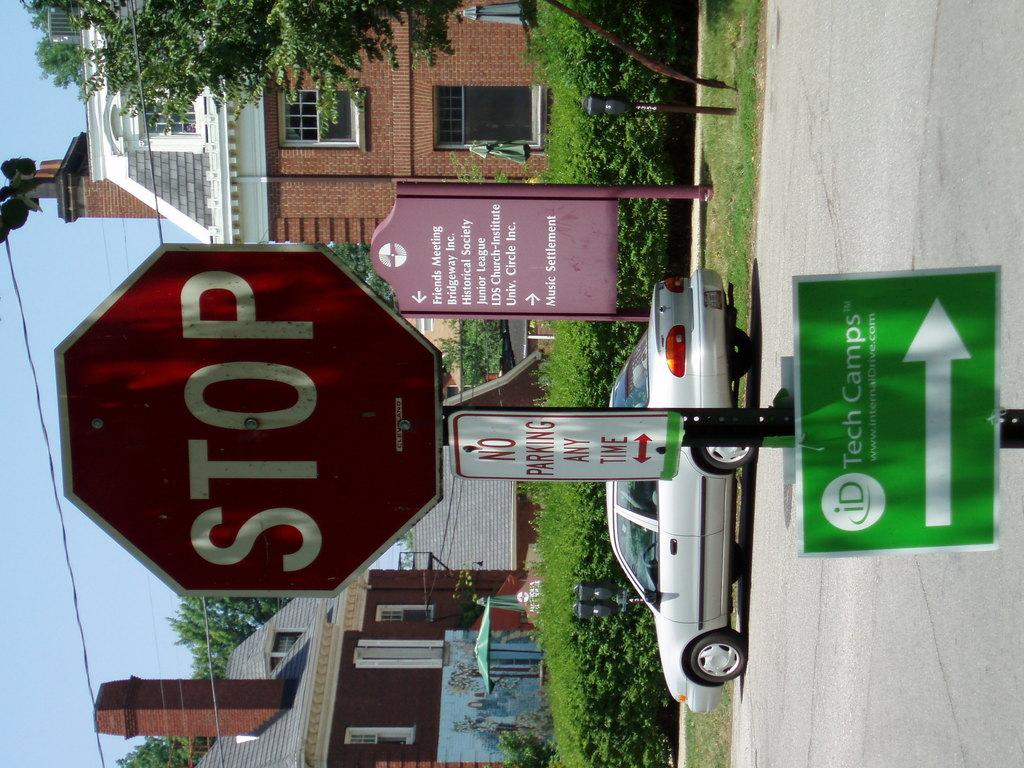<image>
Share a concise interpretation of the image provided. a stop sign that is above a green sign 